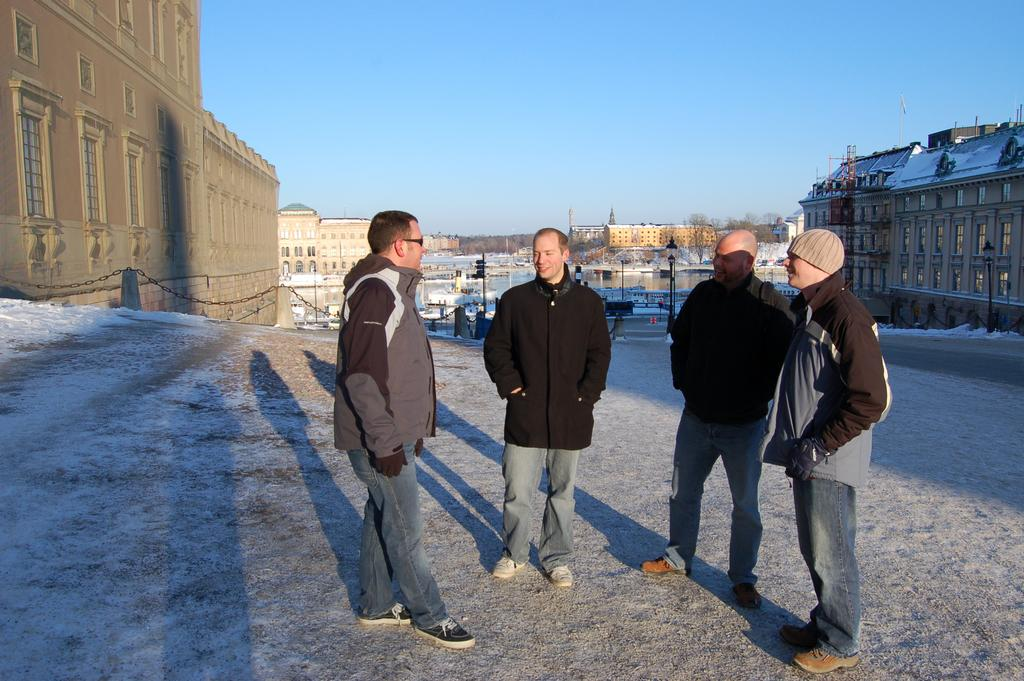How many men are in the image? There are four men in the image. What are the expressions on the men's faces? The men are smiling in the image. Where are the men standing? The men are standing on the ground in the image. What can be seen in the background of the image? There are buildings, trees, water, and some objects visible in the background of the image. The sky is also visible in the background. What type of dog can be seen distributing cars in the image? There is no dog or cars present in the image, and therefore no such activity can be observed. 